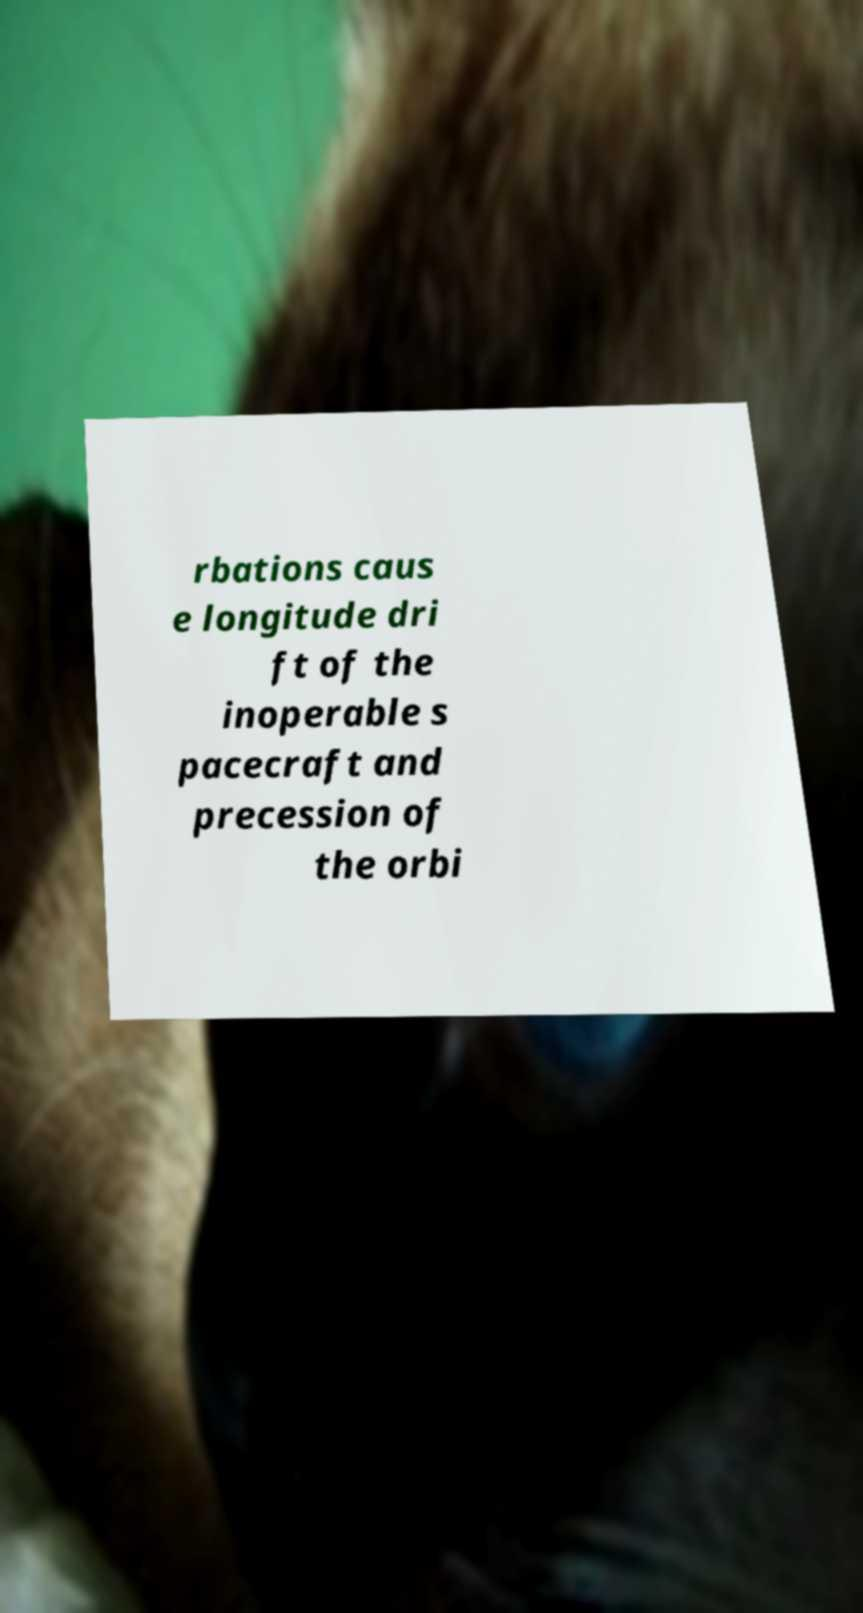There's text embedded in this image that I need extracted. Can you transcribe it verbatim? rbations caus e longitude dri ft of the inoperable s pacecraft and precession of the orbi 